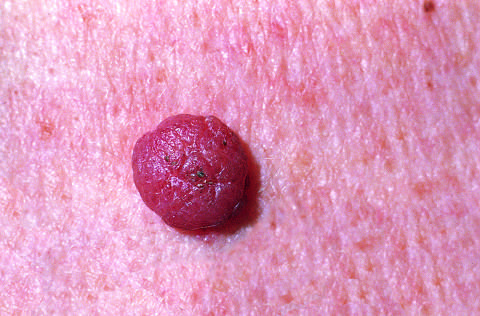what are relatively small, symmetric, and uniformly pigmented?
Answer the question using a single word or phrase. Melanocytic nevi 